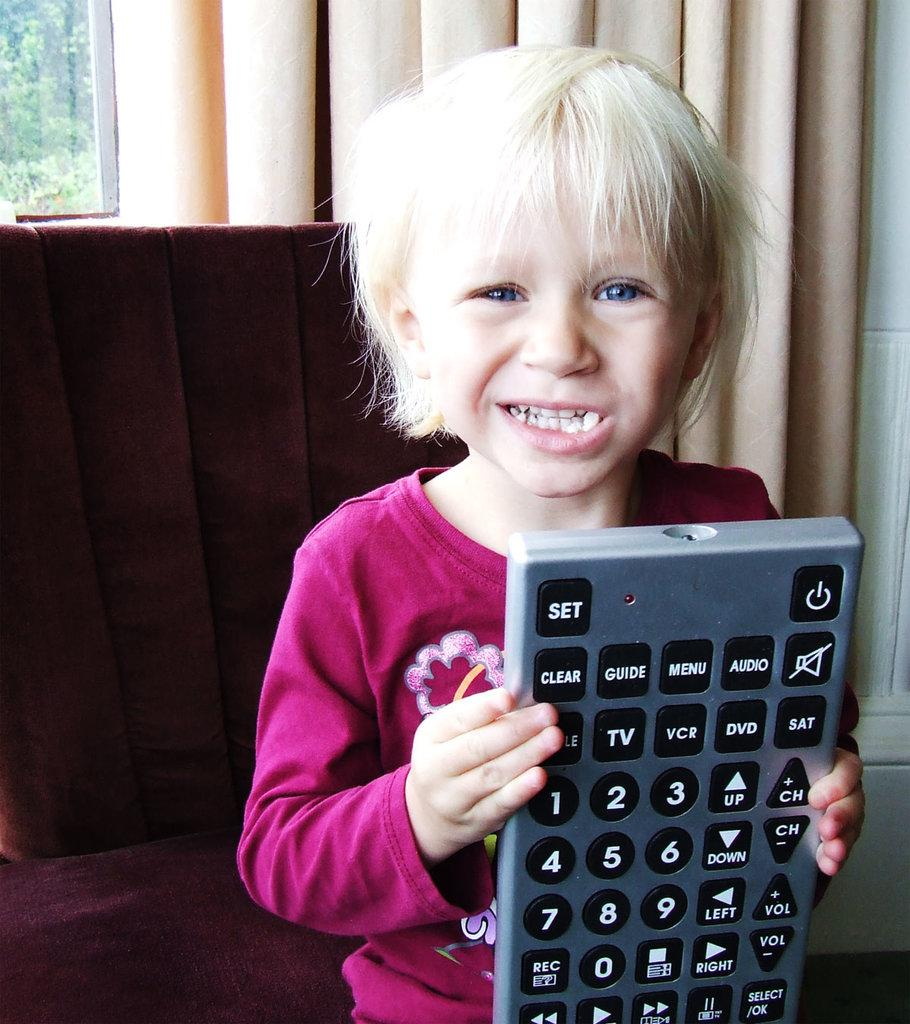Provide a one-sentence caption for the provided image. blonde child in pinkish red top holding giant tv remote with buttons visible such as clear, guide, audio, vcr, dvd, etc. 